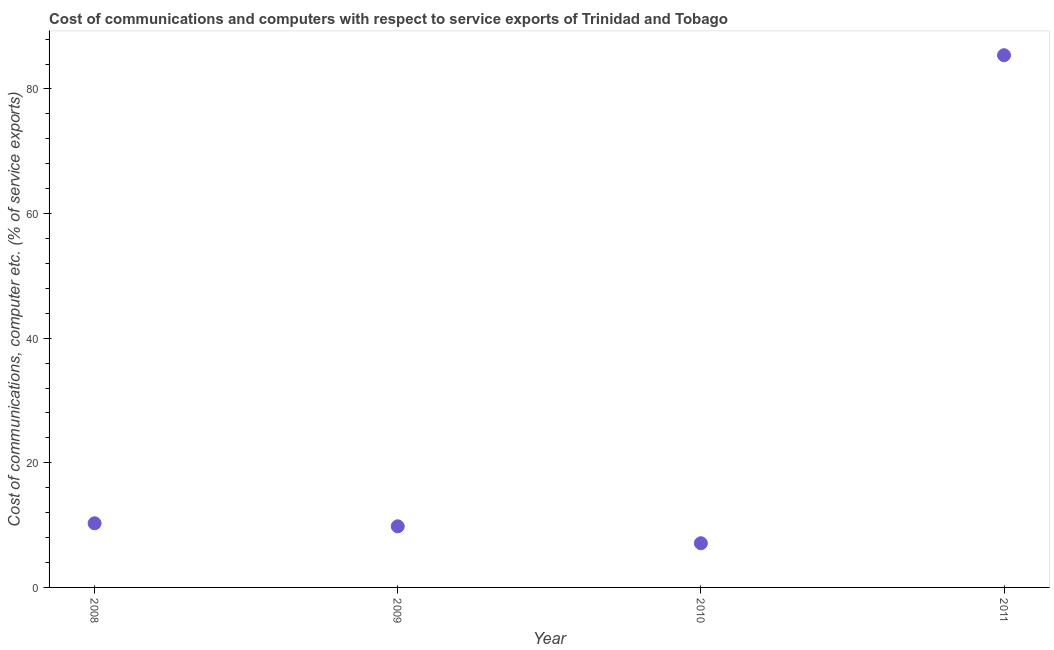What is the cost of communications and computer in 2011?
Offer a terse response. 85.41. Across all years, what is the maximum cost of communications and computer?
Make the answer very short. 85.41. Across all years, what is the minimum cost of communications and computer?
Offer a very short reply. 7.09. In which year was the cost of communications and computer maximum?
Give a very brief answer. 2011. In which year was the cost of communications and computer minimum?
Make the answer very short. 2010. What is the sum of the cost of communications and computer?
Provide a succinct answer. 112.6. What is the difference between the cost of communications and computer in 2008 and 2011?
Make the answer very short. -75.12. What is the average cost of communications and computer per year?
Your answer should be very brief. 28.15. What is the median cost of communications and computer?
Keep it short and to the point. 10.05. In how many years, is the cost of communications and computer greater than 20 %?
Make the answer very short. 1. What is the ratio of the cost of communications and computer in 2008 to that in 2010?
Keep it short and to the point. 1.45. What is the difference between the highest and the second highest cost of communications and computer?
Your answer should be compact. 75.12. What is the difference between the highest and the lowest cost of communications and computer?
Ensure brevity in your answer.  78.32. In how many years, is the cost of communications and computer greater than the average cost of communications and computer taken over all years?
Your response must be concise. 1. How many years are there in the graph?
Provide a short and direct response. 4. What is the difference between two consecutive major ticks on the Y-axis?
Keep it short and to the point. 20. Are the values on the major ticks of Y-axis written in scientific E-notation?
Provide a short and direct response. No. What is the title of the graph?
Offer a very short reply. Cost of communications and computers with respect to service exports of Trinidad and Tobago. What is the label or title of the X-axis?
Ensure brevity in your answer.  Year. What is the label or title of the Y-axis?
Keep it short and to the point. Cost of communications, computer etc. (% of service exports). What is the Cost of communications, computer etc. (% of service exports) in 2008?
Give a very brief answer. 10.29. What is the Cost of communications, computer etc. (% of service exports) in 2009?
Your response must be concise. 9.81. What is the Cost of communications, computer etc. (% of service exports) in 2010?
Give a very brief answer. 7.09. What is the Cost of communications, computer etc. (% of service exports) in 2011?
Keep it short and to the point. 85.41. What is the difference between the Cost of communications, computer etc. (% of service exports) in 2008 and 2009?
Ensure brevity in your answer.  0.49. What is the difference between the Cost of communications, computer etc. (% of service exports) in 2008 and 2010?
Offer a terse response. 3.2. What is the difference between the Cost of communications, computer etc. (% of service exports) in 2008 and 2011?
Provide a short and direct response. -75.12. What is the difference between the Cost of communications, computer etc. (% of service exports) in 2009 and 2010?
Your answer should be compact. 2.71. What is the difference between the Cost of communications, computer etc. (% of service exports) in 2009 and 2011?
Keep it short and to the point. -75.6. What is the difference between the Cost of communications, computer etc. (% of service exports) in 2010 and 2011?
Your response must be concise. -78.32. What is the ratio of the Cost of communications, computer etc. (% of service exports) in 2008 to that in 2010?
Make the answer very short. 1.45. What is the ratio of the Cost of communications, computer etc. (% of service exports) in 2008 to that in 2011?
Offer a terse response. 0.12. What is the ratio of the Cost of communications, computer etc. (% of service exports) in 2009 to that in 2010?
Offer a terse response. 1.38. What is the ratio of the Cost of communications, computer etc. (% of service exports) in 2009 to that in 2011?
Provide a succinct answer. 0.12. What is the ratio of the Cost of communications, computer etc. (% of service exports) in 2010 to that in 2011?
Your answer should be compact. 0.08. 